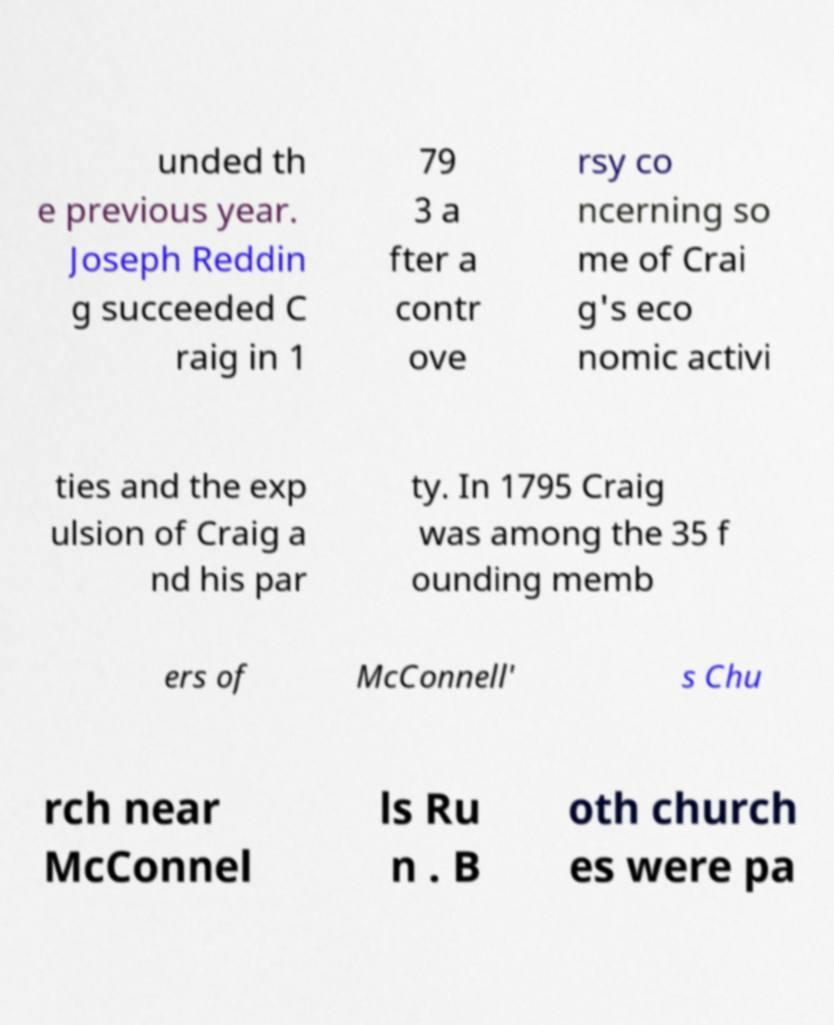Please identify and transcribe the text found in this image. unded th e previous year. Joseph Reddin g succeeded C raig in 1 79 3 a fter a contr ove rsy co ncerning so me of Crai g's eco nomic activi ties and the exp ulsion of Craig a nd his par ty. In 1795 Craig was among the 35 f ounding memb ers of McConnell' s Chu rch near McConnel ls Ru n . B oth church es were pa 